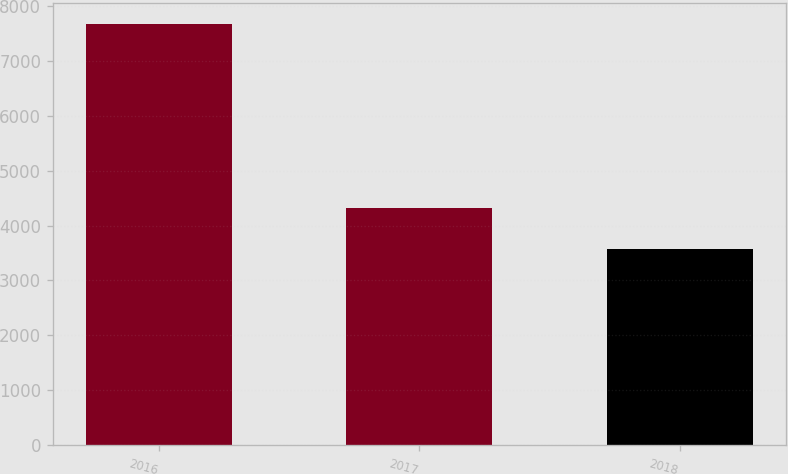Convert chart to OTSL. <chart><loc_0><loc_0><loc_500><loc_500><bar_chart><fcel>2016<fcel>2017<fcel>2018<nl><fcel>7660<fcel>4317<fcel>3568<nl></chart> 